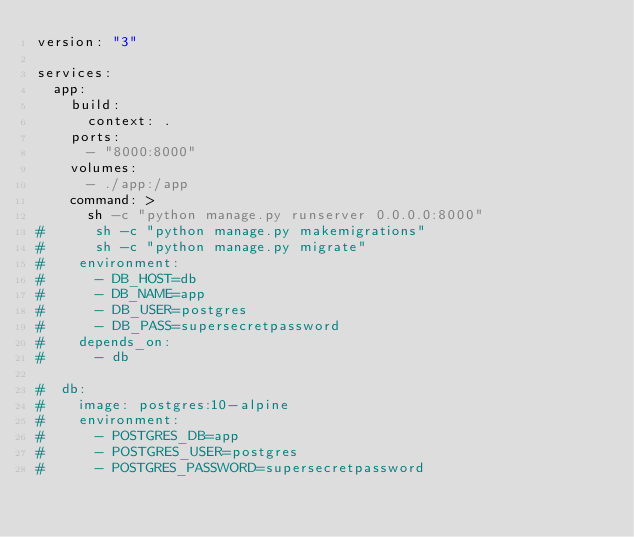<code> <loc_0><loc_0><loc_500><loc_500><_YAML_>version: "3"

services:
  app:
    build:
      context: .
    ports:
      - "8000:8000"
    volumes:
      - ./app:/app
    command: >
      sh -c "python manage.py runserver 0.0.0.0:8000"
#      sh -c "python manage.py makemigrations"
#      sh -c "python manage.py migrate"
#    environment:
#      - DB_HOST=db
#      - DB_NAME=app
#      - DB_USER=postgres
#      - DB_PASS=supersecretpassword
#    depends_on:
#      - db

#  db:
#    image: postgres:10-alpine
#    environment:
#      - POSTGRES_DB=app
#      - POSTGRES_USER=postgres
#      - POSTGRES_PASSWORD=supersecretpassword</code> 